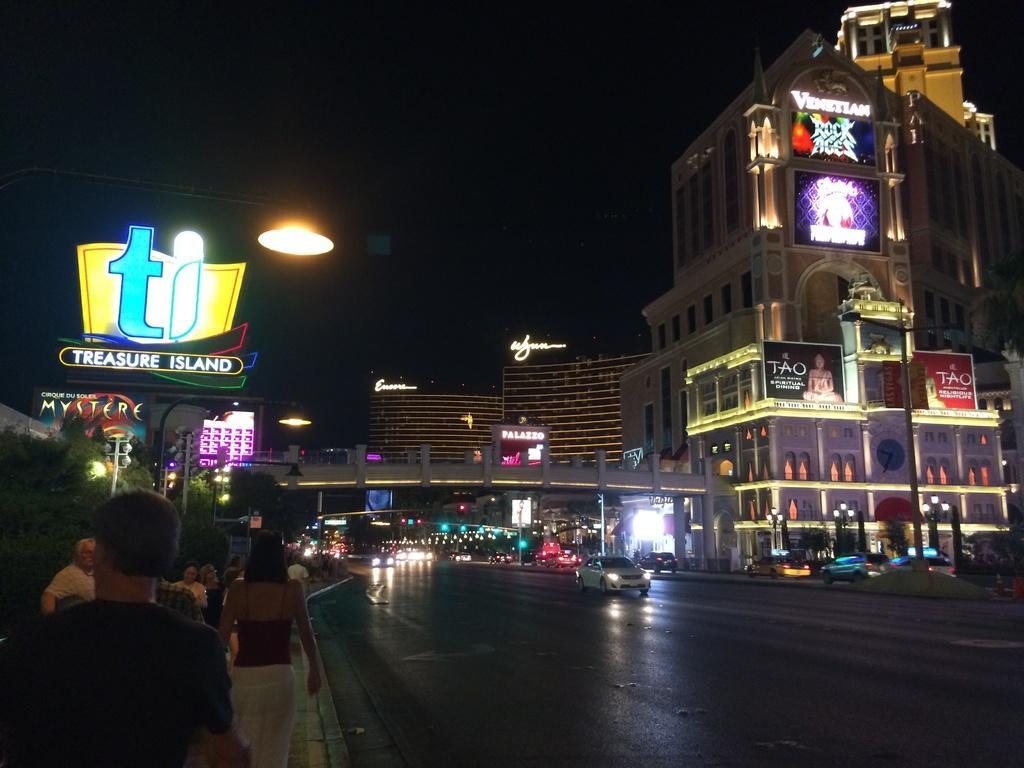In one or two sentences, can you explain what this image depicts? In this picture we can see vehicles on the road and people on the footpath. In the background the sky is dark and we have many buildings. 